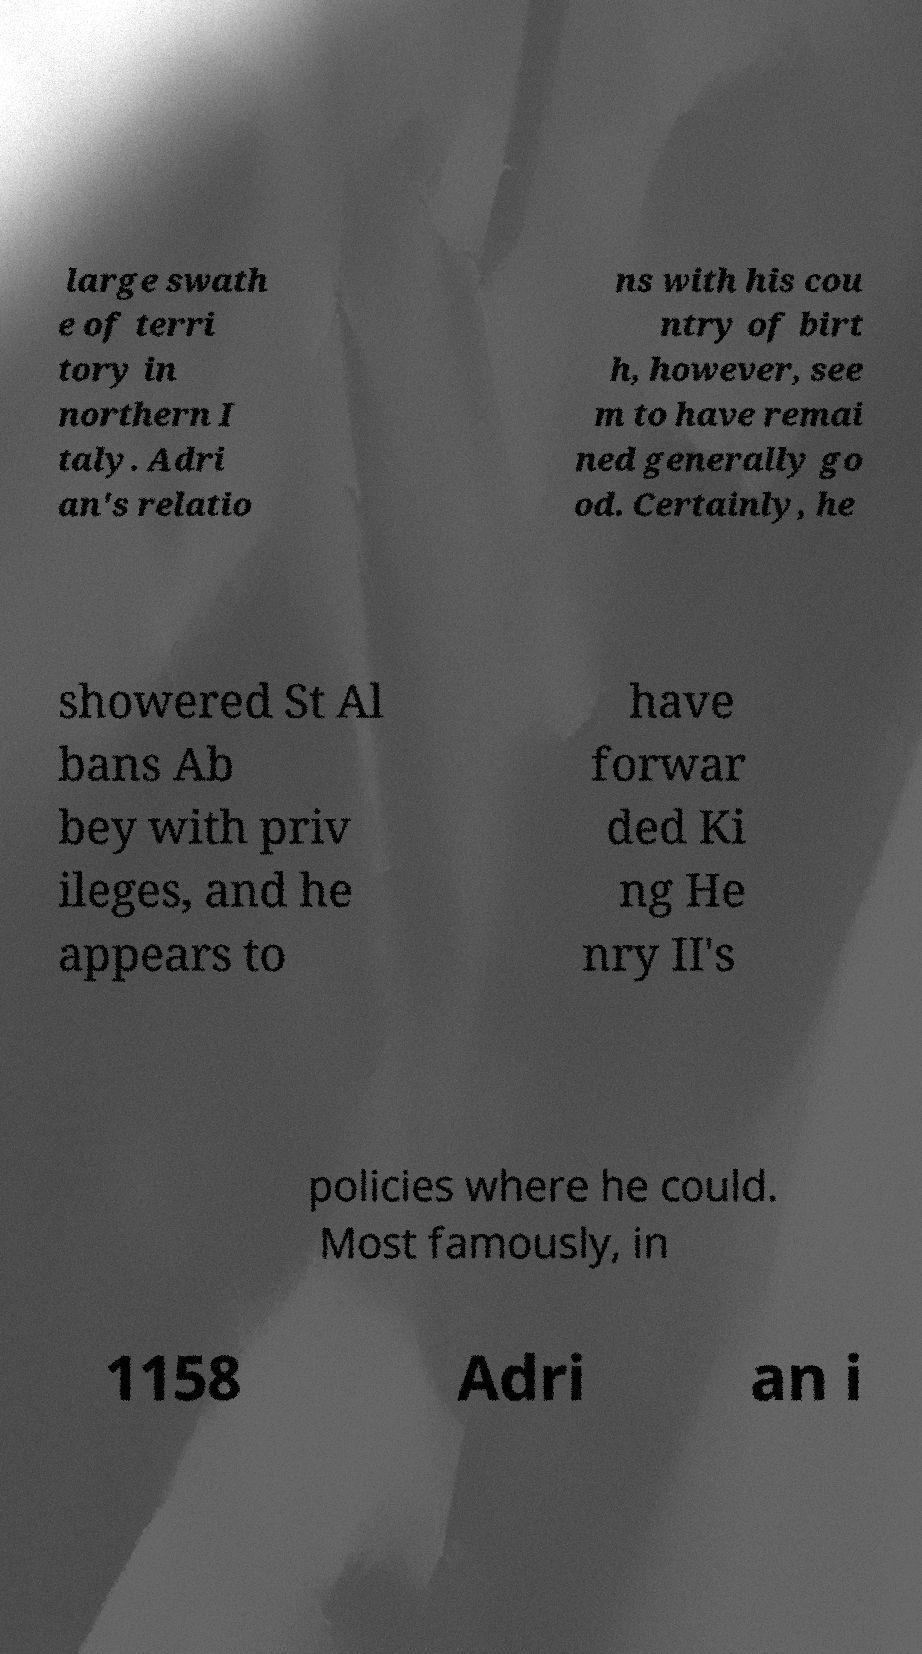What messages or text are displayed in this image? I need them in a readable, typed format. large swath e of terri tory in northern I taly. Adri an's relatio ns with his cou ntry of birt h, however, see m to have remai ned generally go od. Certainly, he showered St Al bans Ab bey with priv ileges, and he appears to have forwar ded Ki ng He nry II's policies where he could. Most famously, in 1158 Adri an i 